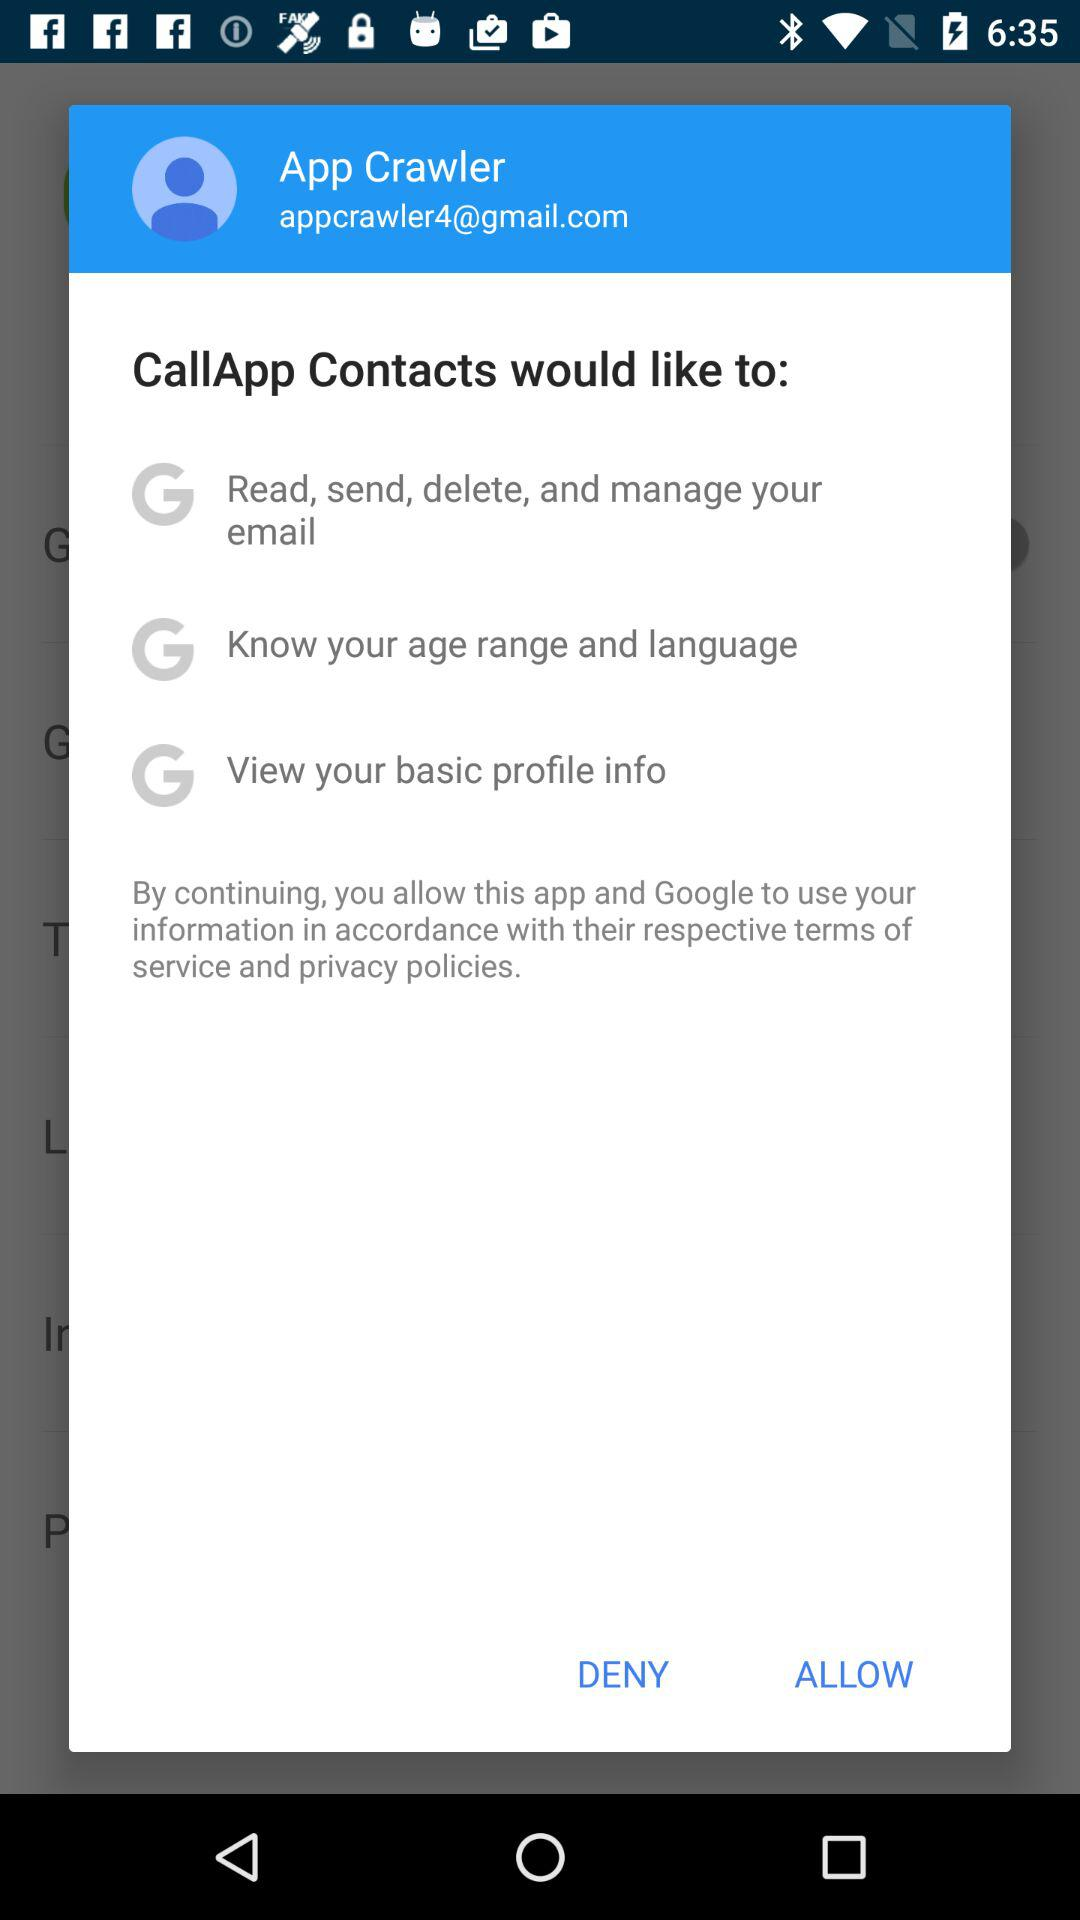What is the username? The username is App Crawler. 